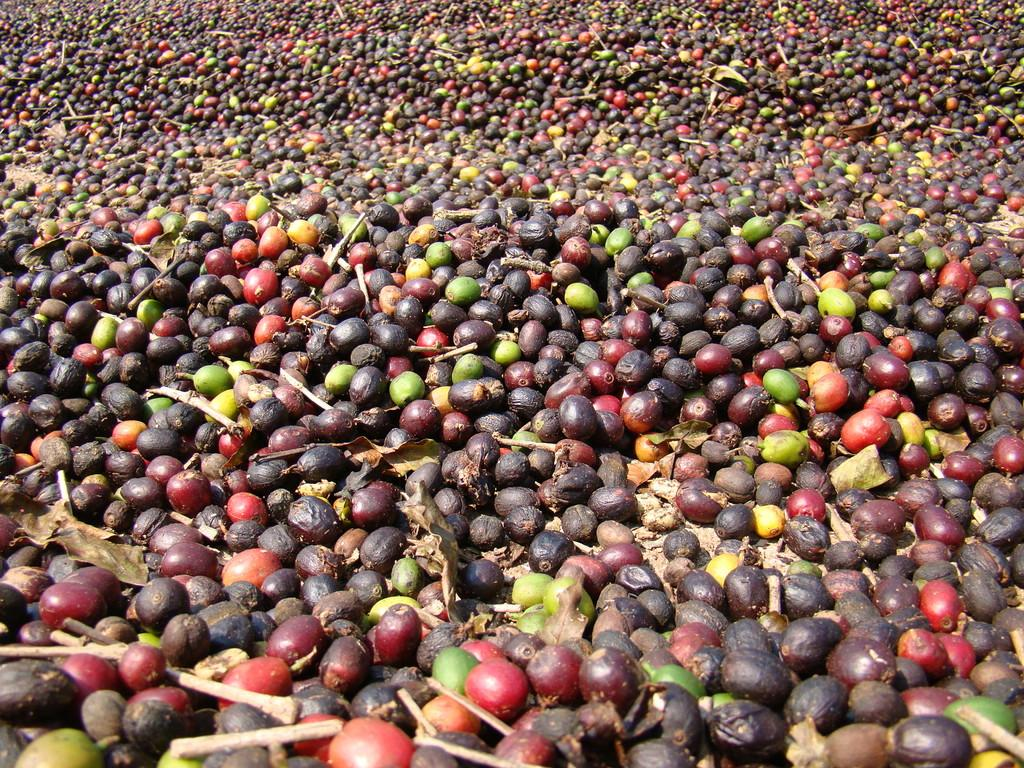What type of fruit is present in the image? There are berries in the image. What other natural elements can be seen in the image? There are twigs and dried leaves in the image. Where is the boundary between the two territories in the image? There is no reference to territories or boundaries in the image; it only features berries, twigs, and dried leaves. 